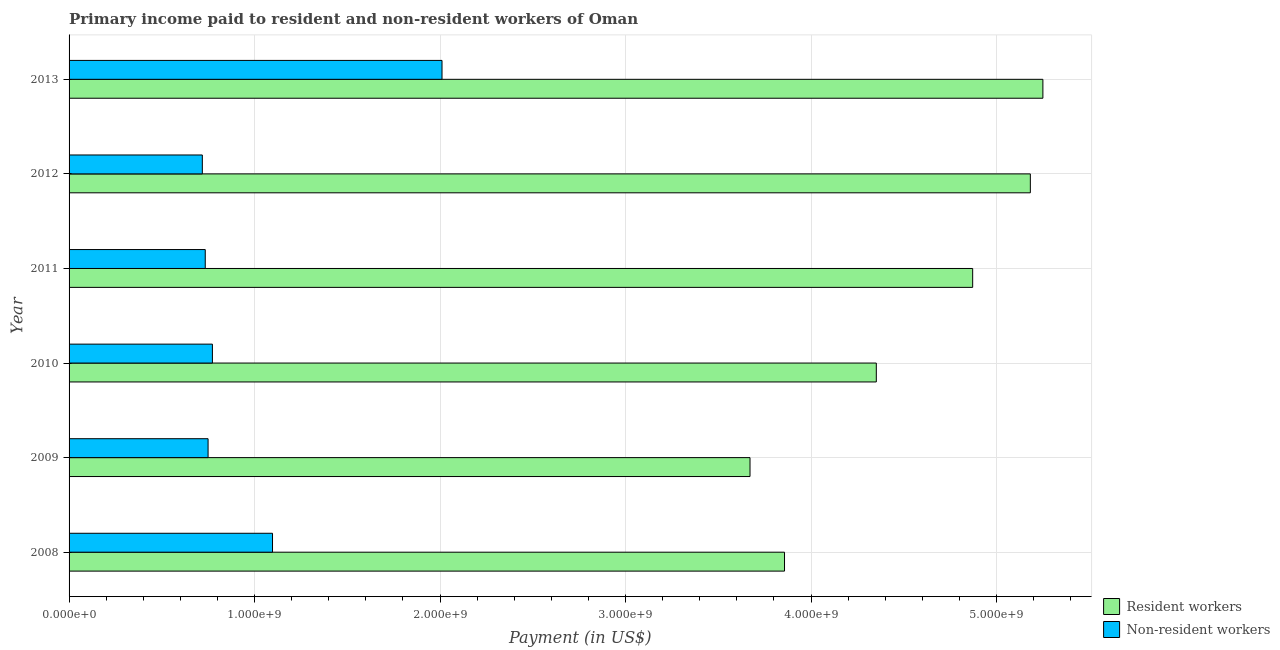How many different coloured bars are there?
Your answer should be compact. 2. Are the number of bars per tick equal to the number of legend labels?
Your answer should be very brief. Yes. Are the number of bars on each tick of the Y-axis equal?
Provide a short and direct response. Yes. How many bars are there on the 5th tick from the bottom?
Provide a succinct answer. 2. In how many cases, is the number of bars for a given year not equal to the number of legend labels?
Your response must be concise. 0. What is the payment made to resident workers in 2008?
Offer a very short reply. 3.86e+09. Across all years, what is the maximum payment made to non-resident workers?
Provide a short and direct response. 2.01e+09. Across all years, what is the minimum payment made to non-resident workers?
Offer a very short reply. 7.18e+08. In which year was the payment made to resident workers maximum?
Your response must be concise. 2013. In which year was the payment made to non-resident workers minimum?
Provide a succinct answer. 2012. What is the total payment made to resident workers in the graph?
Your answer should be compact. 2.72e+1. What is the difference between the payment made to non-resident workers in 2008 and that in 2010?
Keep it short and to the point. 3.24e+08. What is the difference between the payment made to non-resident workers in 2013 and the payment made to resident workers in 2012?
Your answer should be compact. -3.17e+09. What is the average payment made to non-resident workers per year?
Ensure brevity in your answer.  1.01e+09. In the year 2011, what is the difference between the payment made to resident workers and payment made to non-resident workers?
Provide a short and direct response. 4.14e+09. In how many years, is the payment made to non-resident workers greater than 5200000000 US$?
Ensure brevity in your answer.  0. What is the ratio of the payment made to resident workers in 2009 to that in 2013?
Your answer should be very brief. 0.7. What is the difference between the highest and the second highest payment made to resident workers?
Make the answer very short. 6.77e+07. What is the difference between the highest and the lowest payment made to non-resident workers?
Give a very brief answer. 1.29e+09. In how many years, is the payment made to resident workers greater than the average payment made to resident workers taken over all years?
Keep it short and to the point. 3. Is the sum of the payment made to resident workers in 2008 and 2010 greater than the maximum payment made to non-resident workers across all years?
Make the answer very short. Yes. What does the 1st bar from the top in 2011 represents?
Give a very brief answer. Non-resident workers. What does the 1st bar from the bottom in 2008 represents?
Provide a short and direct response. Resident workers. How many years are there in the graph?
Give a very brief answer. 6. What is the difference between two consecutive major ticks on the X-axis?
Provide a succinct answer. 1.00e+09. Are the values on the major ticks of X-axis written in scientific E-notation?
Your answer should be compact. Yes. Does the graph contain any zero values?
Offer a very short reply. No. What is the title of the graph?
Offer a terse response. Primary income paid to resident and non-resident workers of Oman. Does "Netherlands" appear as one of the legend labels in the graph?
Ensure brevity in your answer.  No. What is the label or title of the X-axis?
Offer a very short reply. Payment (in US$). What is the Payment (in US$) in Resident workers in 2008?
Your response must be concise. 3.86e+09. What is the Payment (in US$) of Non-resident workers in 2008?
Your answer should be compact. 1.10e+09. What is the Payment (in US$) in Resident workers in 2009?
Offer a terse response. 3.67e+09. What is the Payment (in US$) of Non-resident workers in 2009?
Your answer should be very brief. 7.49e+08. What is the Payment (in US$) in Resident workers in 2010?
Give a very brief answer. 4.35e+09. What is the Payment (in US$) in Non-resident workers in 2010?
Offer a terse response. 7.73e+08. What is the Payment (in US$) in Resident workers in 2011?
Keep it short and to the point. 4.87e+09. What is the Payment (in US$) in Non-resident workers in 2011?
Offer a very short reply. 7.34e+08. What is the Payment (in US$) in Resident workers in 2012?
Your answer should be compact. 5.18e+09. What is the Payment (in US$) in Non-resident workers in 2012?
Your response must be concise. 7.18e+08. What is the Payment (in US$) of Resident workers in 2013?
Ensure brevity in your answer.  5.25e+09. What is the Payment (in US$) of Non-resident workers in 2013?
Provide a short and direct response. 2.01e+09. Across all years, what is the maximum Payment (in US$) in Resident workers?
Provide a short and direct response. 5.25e+09. Across all years, what is the maximum Payment (in US$) in Non-resident workers?
Make the answer very short. 2.01e+09. Across all years, what is the minimum Payment (in US$) of Resident workers?
Your answer should be compact. 3.67e+09. Across all years, what is the minimum Payment (in US$) of Non-resident workers?
Your answer should be compact. 7.18e+08. What is the total Payment (in US$) of Resident workers in the graph?
Give a very brief answer. 2.72e+1. What is the total Payment (in US$) of Non-resident workers in the graph?
Offer a terse response. 6.08e+09. What is the difference between the Payment (in US$) in Resident workers in 2008 and that in 2009?
Your answer should be compact. 1.86e+08. What is the difference between the Payment (in US$) in Non-resident workers in 2008 and that in 2009?
Provide a succinct answer. 3.47e+08. What is the difference between the Payment (in US$) in Resident workers in 2008 and that in 2010?
Ensure brevity in your answer.  -4.95e+08. What is the difference between the Payment (in US$) of Non-resident workers in 2008 and that in 2010?
Your answer should be compact. 3.24e+08. What is the difference between the Payment (in US$) of Resident workers in 2008 and that in 2011?
Provide a succinct answer. -1.01e+09. What is the difference between the Payment (in US$) of Non-resident workers in 2008 and that in 2011?
Offer a terse response. 3.63e+08. What is the difference between the Payment (in US$) of Resident workers in 2008 and that in 2012?
Your answer should be very brief. -1.33e+09. What is the difference between the Payment (in US$) in Non-resident workers in 2008 and that in 2012?
Your answer should be very brief. 3.78e+08. What is the difference between the Payment (in US$) of Resident workers in 2008 and that in 2013?
Ensure brevity in your answer.  -1.39e+09. What is the difference between the Payment (in US$) of Non-resident workers in 2008 and that in 2013?
Your answer should be very brief. -9.14e+08. What is the difference between the Payment (in US$) of Resident workers in 2009 and that in 2010?
Provide a short and direct response. -6.81e+08. What is the difference between the Payment (in US$) of Non-resident workers in 2009 and that in 2010?
Keep it short and to the point. -2.33e+07. What is the difference between the Payment (in US$) in Resident workers in 2009 and that in 2011?
Offer a very short reply. -1.20e+09. What is the difference between the Payment (in US$) of Non-resident workers in 2009 and that in 2011?
Your answer should be very brief. 1.52e+07. What is the difference between the Payment (in US$) in Resident workers in 2009 and that in 2012?
Offer a terse response. -1.51e+09. What is the difference between the Payment (in US$) of Non-resident workers in 2009 and that in 2012?
Your response must be concise. 3.10e+07. What is the difference between the Payment (in US$) in Resident workers in 2009 and that in 2013?
Ensure brevity in your answer.  -1.58e+09. What is the difference between the Payment (in US$) of Non-resident workers in 2009 and that in 2013?
Give a very brief answer. -1.26e+09. What is the difference between the Payment (in US$) in Resident workers in 2010 and that in 2011?
Your response must be concise. -5.19e+08. What is the difference between the Payment (in US$) in Non-resident workers in 2010 and that in 2011?
Keep it short and to the point. 3.86e+07. What is the difference between the Payment (in US$) in Resident workers in 2010 and that in 2012?
Offer a very short reply. -8.30e+08. What is the difference between the Payment (in US$) in Non-resident workers in 2010 and that in 2012?
Your answer should be compact. 5.43e+07. What is the difference between the Payment (in US$) in Resident workers in 2010 and that in 2013?
Your answer should be very brief. -8.98e+08. What is the difference between the Payment (in US$) of Non-resident workers in 2010 and that in 2013?
Offer a very short reply. -1.24e+09. What is the difference between the Payment (in US$) in Resident workers in 2011 and that in 2012?
Offer a very short reply. -3.11e+08. What is the difference between the Payment (in US$) of Non-resident workers in 2011 and that in 2012?
Give a very brief answer. 1.58e+07. What is the difference between the Payment (in US$) of Resident workers in 2011 and that in 2013?
Offer a terse response. -3.79e+08. What is the difference between the Payment (in US$) of Non-resident workers in 2011 and that in 2013?
Keep it short and to the point. -1.28e+09. What is the difference between the Payment (in US$) of Resident workers in 2012 and that in 2013?
Keep it short and to the point. -6.77e+07. What is the difference between the Payment (in US$) in Non-resident workers in 2012 and that in 2013?
Provide a short and direct response. -1.29e+09. What is the difference between the Payment (in US$) in Resident workers in 2008 and the Payment (in US$) in Non-resident workers in 2009?
Your answer should be compact. 3.11e+09. What is the difference between the Payment (in US$) of Resident workers in 2008 and the Payment (in US$) of Non-resident workers in 2010?
Make the answer very short. 3.08e+09. What is the difference between the Payment (in US$) of Resident workers in 2008 and the Payment (in US$) of Non-resident workers in 2011?
Ensure brevity in your answer.  3.12e+09. What is the difference between the Payment (in US$) of Resident workers in 2008 and the Payment (in US$) of Non-resident workers in 2012?
Your answer should be compact. 3.14e+09. What is the difference between the Payment (in US$) of Resident workers in 2008 and the Payment (in US$) of Non-resident workers in 2013?
Keep it short and to the point. 1.85e+09. What is the difference between the Payment (in US$) of Resident workers in 2009 and the Payment (in US$) of Non-resident workers in 2010?
Provide a succinct answer. 2.90e+09. What is the difference between the Payment (in US$) in Resident workers in 2009 and the Payment (in US$) in Non-resident workers in 2011?
Give a very brief answer. 2.94e+09. What is the difference between the Payment (in US$) of Resident workers in 2009 and the Payment (in US$) of Non-resident workers in 2012?
Your answer should be very brief. 2.95e+09. What is the difference between the Payment (in US$) of Resident workers in 2009 and the Payment (in US$) of Non-resident workers in 2013?
Give a very brief answer. 1.66e+09. What is the difference between the Payment (in US$) in Resident workers in 2010 and the Payment (in US$) in Non-resident workers in 2011?
Your answer should be very brief. 3.62e+09. What is the difference between the Payment (in US$) of Resident workers in 2010 and the Payment (in US$) of Non-resident workers in 2012?
Keep it short and to the point. 3.63e+09. What is the difference between the Payment (in US$) in Resident workers in 2010 and the Payment (in US$) in Non-resident workers in 2013?
Offer a terse response. 2.34e+09. What is the difference between the Payment (in US$) of Resident workers in 2011 and the Payment (in US$) of Non-resident workers in 2012?
Offer a terse response. 4.15e+09. What is the difference between the Payment (in US$) in Resident workers in 2011 and the Payment (in US$) in Non-resident workers in 2013?
Ensure brevity in your answer.  2.86e+09. What is the difference between the Payment (in US$) in Resident workers in 2012 and the Payment (in US$) in Non-resident workers in 2013?
Your answer should be very brief. 3.17e+09. What is the average Payment (in US$) in Resident workers per year?
Keep it short and to the point. 4.53e+09. What is the average Payment (in US$) of Non-resident workers per year?
Keep it short and to the point. 1.01e+09. In the year 2008, what is the difference between the Payment (in US$) of Resident workers and Payment (in US$) of Non-resident workers?
Your answer should be very brief. 2.76e+09. In the year 2009, what is the difference between the Payment (in US$) in Resident workers and Payment (in US$) in Non-resident workers?
Provide a succinct answer. 2.92e+09. In the year 2010, what is the difference between the Payment (in US$) in Resident workers and Payment (in US$) in Non-resident workers?
Keep it short and to the point. 3.58e+09. In the year 2011, what is the difference between the Payment (in US$) in Resident workers and Payment (in US$) in Non-resident workers?
Offer a terse response. 4.14e+09. In the year 2012, what is the difference between the Payment (in US$) of Resident workers and Payment (in US$) of Non-resident workers?
Your answer should be very brief. 4.46e+09. In the year 2013, what is the difference between the Payment (in US$) in Resident workers and Payment (in US$) in Non-resident workers?
Offer a terse response. 3.24e+09. What is the ratio of the Payment (in US$) of Resident workers in 2008 to that in 2009?
Provide a succinct answer. 1.05. What is the ratio of the Payment (in US$) of Non-resident workers in 2008 to that in 2009?
Your answer should be compact. 1.46. What is the ratio of the Payment (in US$) in Resident workers in 2008 to that in 2010?
Keep it short and to the point. 0.89. What is the ratio of the Payment (in US$) in Non-resident workers in 2008 to that in 2010?
Offer a very short reply. 1.42. What is the ratio of the Payment (in US$) of Resident workers in 2008 to that in 2011?
Provide a short and direct response. 0.79. What is the ratio of the Payment (in US$) of Non-resident workers in 2008 to that in 2011?
Your response must be concise. 1.49. What is the ratio of the Payment (in US$) in Resident workers in 2008 to that in 2012?
Keep it short and to the point. 0.74. What is the ratio of the Payment (in US$) of Non-resident workers in 2008 to that in 2012?
Provide a succinct answer. 1.53. What is the ratio of the Payment (in US$) of Resident workers in 2008 to that in 2013?
Provide a short and direct response. 0.73. What is the ratio of the Payment (in US$) in Non-resident workers in 2008 to that in 2013?
Your answer should be compact. 0.55. What is the ratio of the Payment (in US$) in Resident workers in 2009 to that in 2010?
Your answer should be very brief. 0.84. What is the ratio of the Payment (in US$) in Non-resident workers in 2009 to that in 2010?
Give a very brief answer. 0.97. What is the ratio of the Payment (in US$) in Resident workers in 2009 to that in 2011?
Make the answer very short. 0.75. What is the ratio of the Payment (in US$) of Non-resident workers in 2009 to that in 2011?
Provide a succinct answer. 1.02. What is the ratio of the Payment (in US$) of Resident workers in 2009 to that in 2012?
Make the answer very short. 0.71. What is the ratio of the Payment (in US$) in Non-resident workers in 2009 to that in 2012?
Your response must be concise. 1.04. What is the ratio of the Payment (in US$) of Resident workers in 2009 to that in 2013?
Keep it short and to the point. 0.7. What is the ratio of the Payment (in US$) in Non-resident workers in 2009 to that in 2013?
Provide a short and direct response. 0.37. What is the ratio of the Payment (in US$) in Resident workers in 2010 to that in 2011?
Ensure brevity in your answer.  0.89. What is the ratio of the Payment (in US$) of Non-resident workers in 2010 to that in 2011?
Your answer should be compact. 1.05. What is the ratio of the Payment (in US$) of Resident workers in 2010 to that in 2012?
Provide a succinct answer. 0.84. What is the ratio of the Payment (in US$) in Non-resident workers in 2010 to that in 2012?
Keep it short and to the point. 1.08. What is the ratio of the Payment (in US$) of Resident workers in 2010 to that in 2013?
Your response must be concise. 0.83. What is the ratio of the Payment (in US$) in Non-resident workers in 2010 to that in 2013?
Your answer should be very brief. 0.38. What is the ratio of the Payment (in US$) in Resident workers in 2011 to that in 2013?
Make the answer very short. 0.93. What is the ratio of the Payment (in US$) of Non-resident workers in 2011 to that in 2013?
Your answer should be compact. 0.37. What is the ratio of the Payment (in US$) of Resident workers in 2012 to that in 2013?
Your response must be concise. 0.99. What is the ratio of the Payment (in US$) in Non-resident workers in 2012 to that in 2013?
Your response must be concise. 0.36. What is the difference between the highest and the second highest Payment (in US$) in Resident workers?
Offer a terse response. 6.77e+07. What is the difference between the highest and the second highest Payment (in US$) of Non-resident workers?
Give a very brief answer. 9.14e+08. What is the difference between the highest and the lowest Payment (in US$) of Resident workers?
Keep it short and to the point. 1.58e+09. What is the difference between the highest and the lowest Payment (in US$) of Non-resident workers?
Offer a terse response. 1.29e+09. 